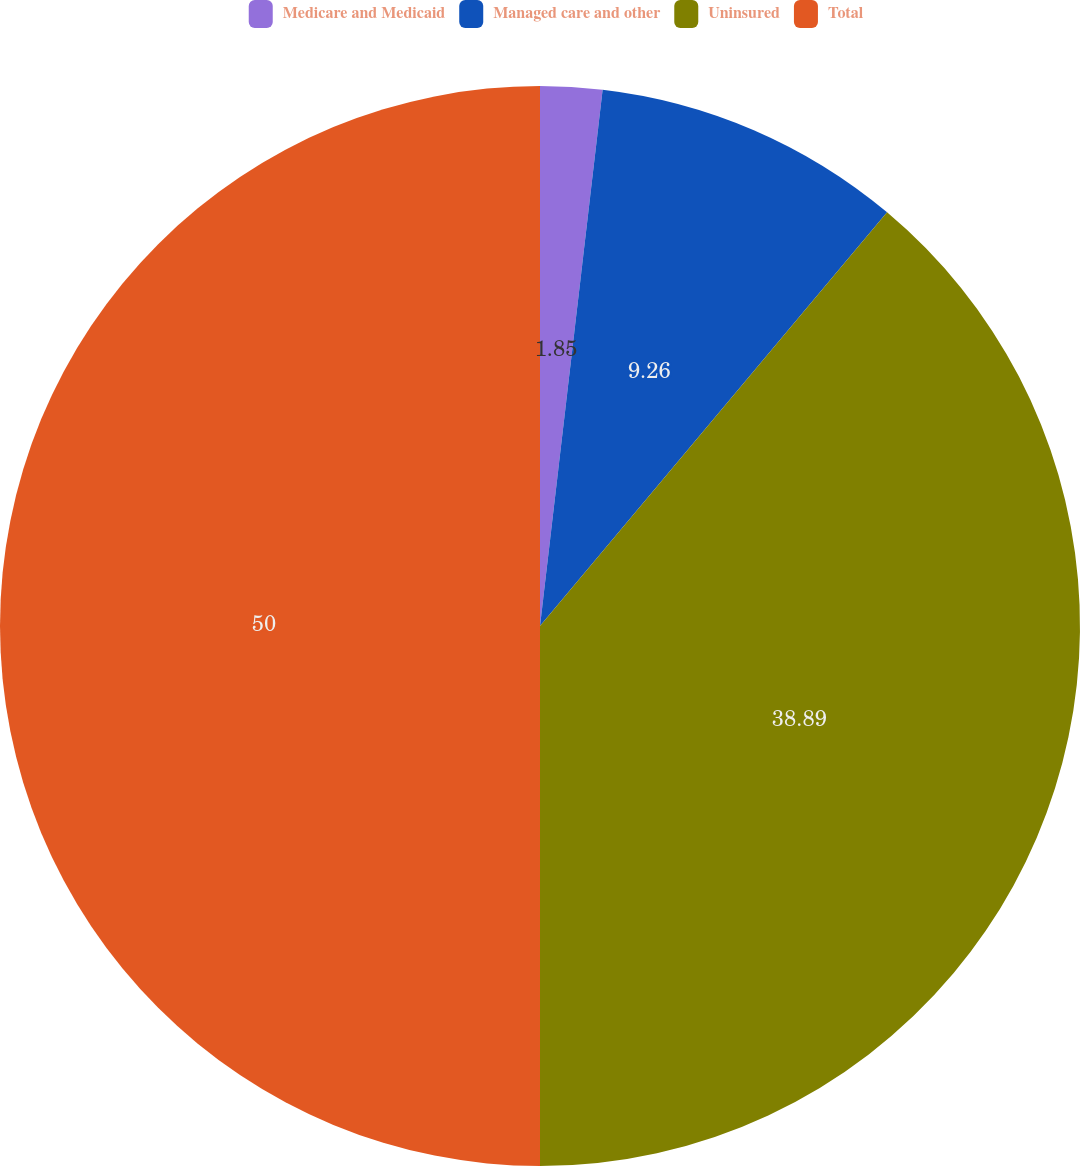Convert chart to OTSL. <chart><loc_0><loc_0><loc_500><loc_500><pie_chart><fcel>Medicare and Medicaid<fcel>Managed care and other<fcel>Uninsured<fcel>Total<nl><fcel>1.85%<fcel>9.26%<fcel>38.89%<fcel>50.0%<nl></chart> 